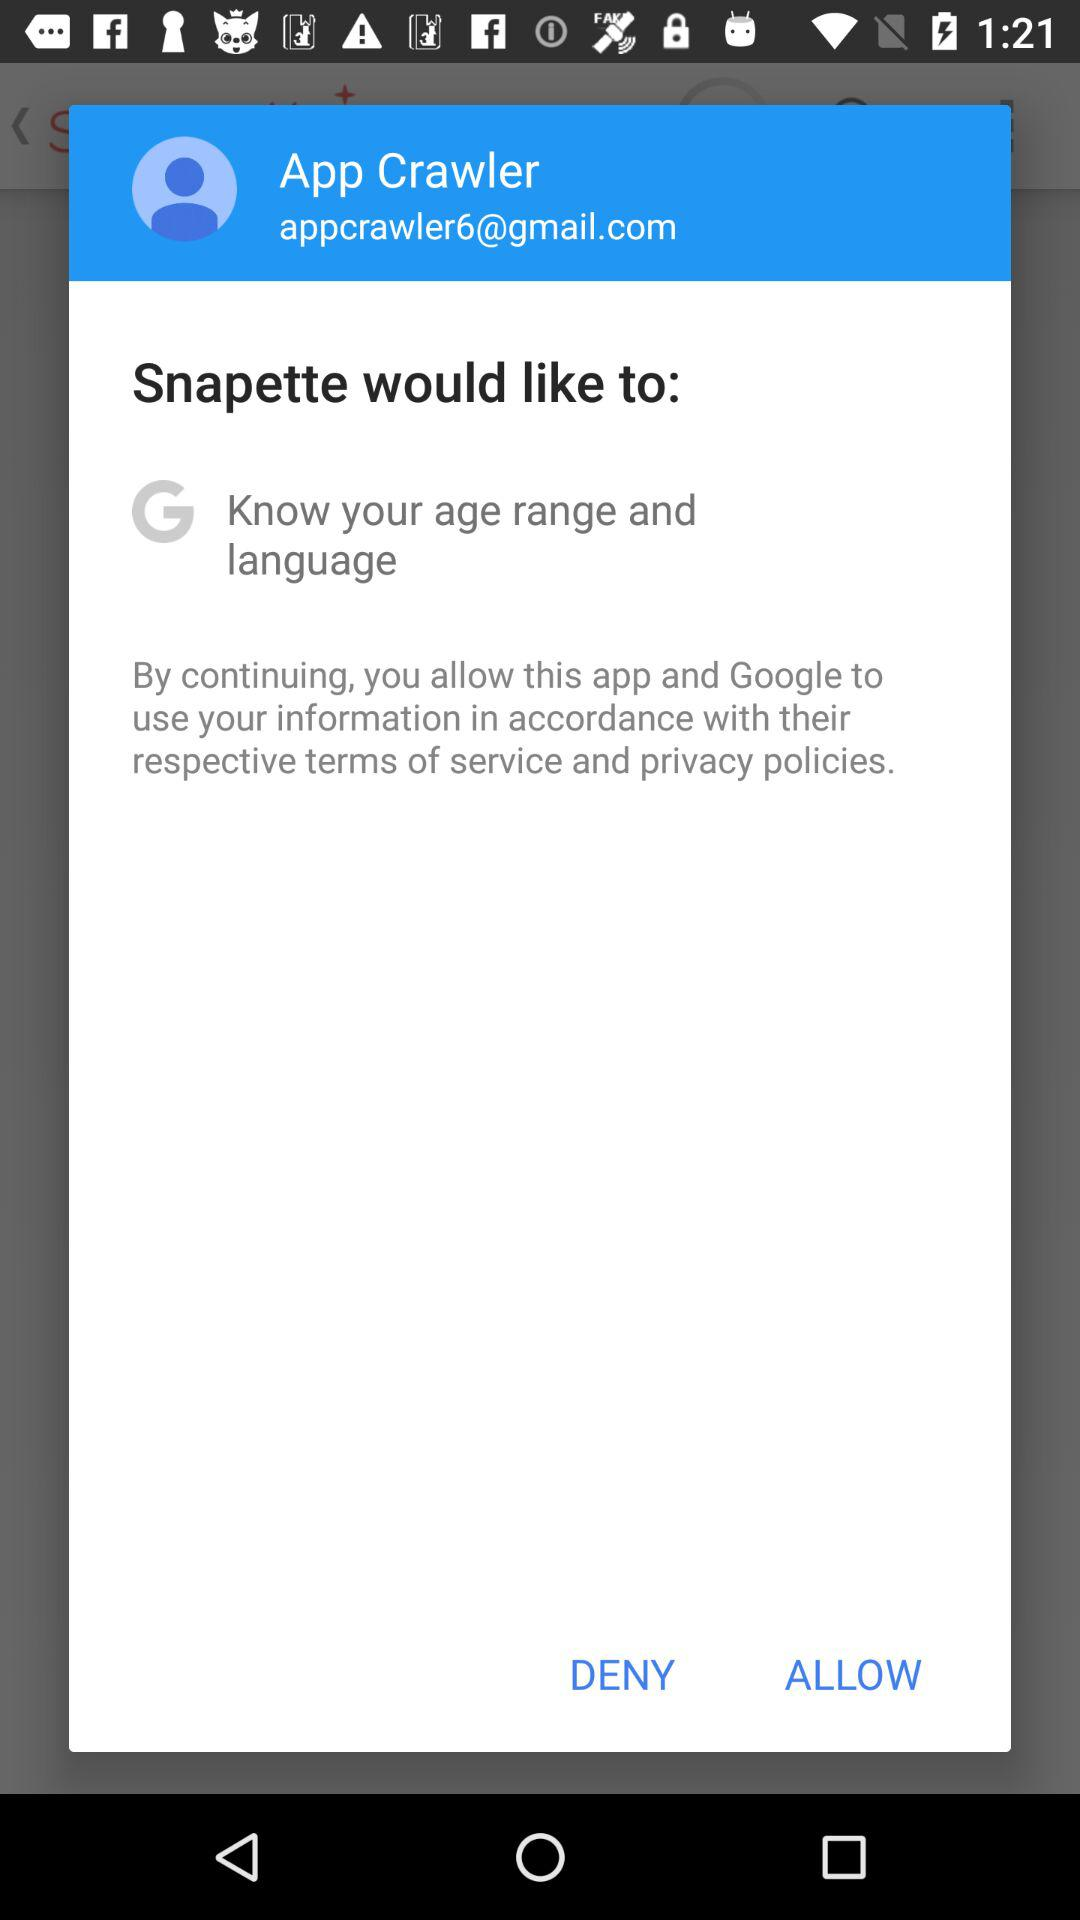What is the name of the user? The name of the user is App Crawler. 